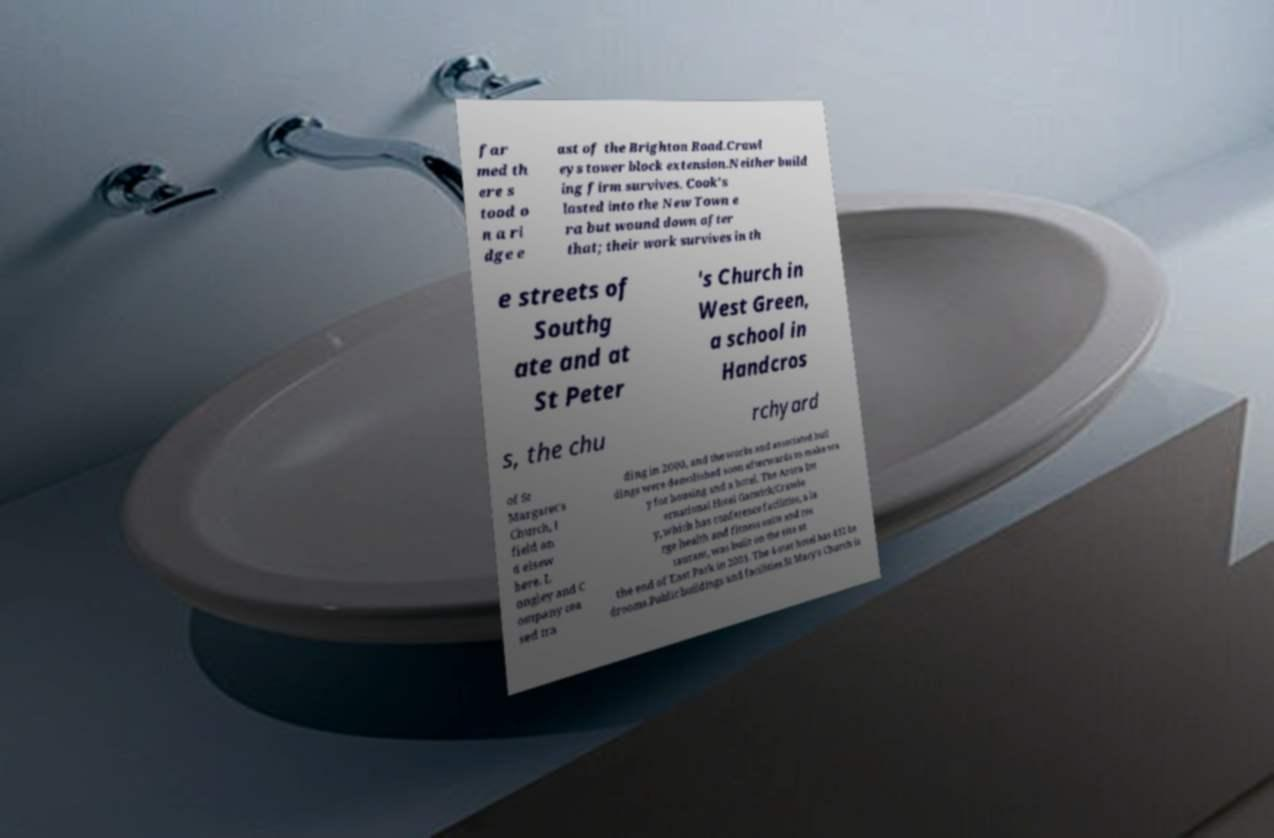There's text embedded in this image that I need extracted. Can you transcribe it verbatim? far med th ere s tood o n a ri dge e ast of the Brighton Road.Crawl eys tower block extension.Neither build ing firm survives. Cook's lasted into the New Town e ra but wound down after that; their work survives in th e streets of Southg ate and at St Peter 's Church in West Green, a school in Handcros s, the chu rchyard of St Margaret's Church, I field an d elsew here. L ongley and C ompany cea sed tra ding in 2000, and the works and associated buil dings were demolished soon afterwards to make wa y for housing and a hotel. The Arora Int ernational Hotel Gatwick/Crawle y, which has conference facilities, a la rge health and fitness suite and res taurant, was built on the site at the end of East Park in 2001. The 4-star hotel has 432 be drooms.Public buildings and facilities.St Mary's Church is 